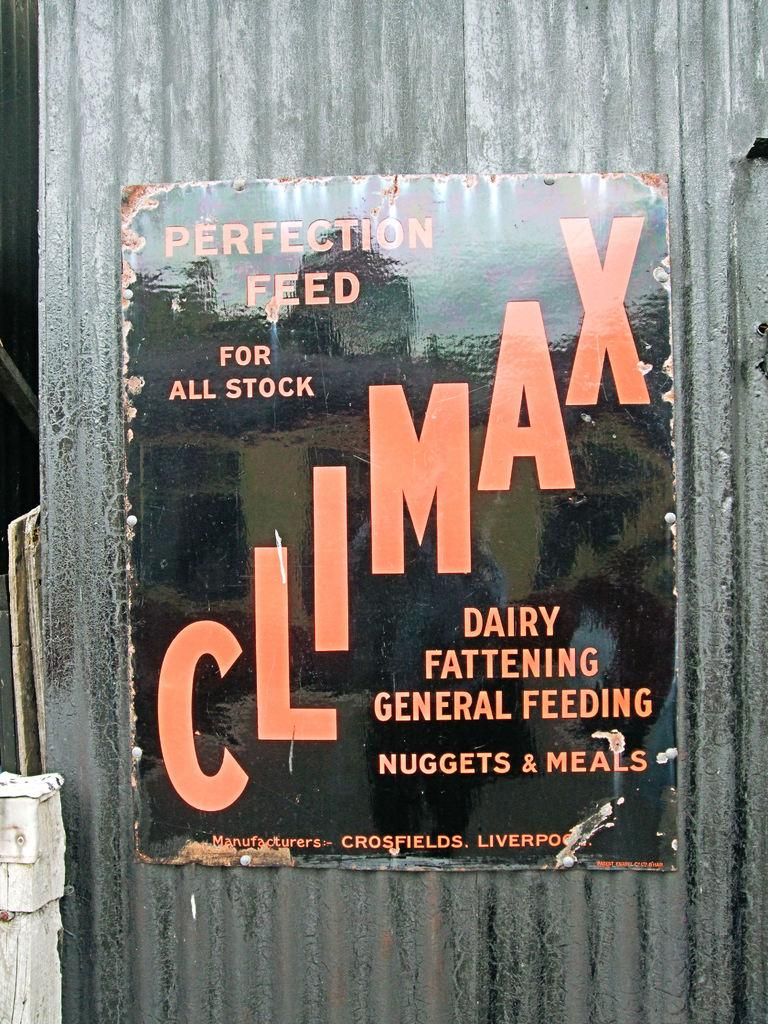<image>
Write a terse but informative summary of the picture. A sign advertises climax as the perfect feed for animals. 